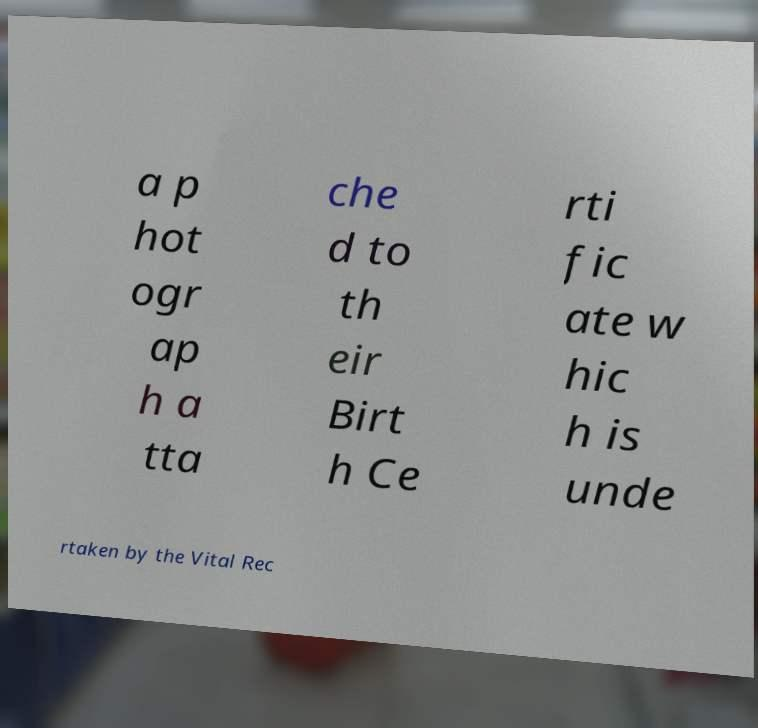Can you read and provide the text displayed in the image?This photo seems to have some interesting text. Can you extract and type it out for me? a p hot ogr ap h a tta che d to th eir Birt h Ce rti fic ate w hic h is unde rtaken by the Vital Rec 